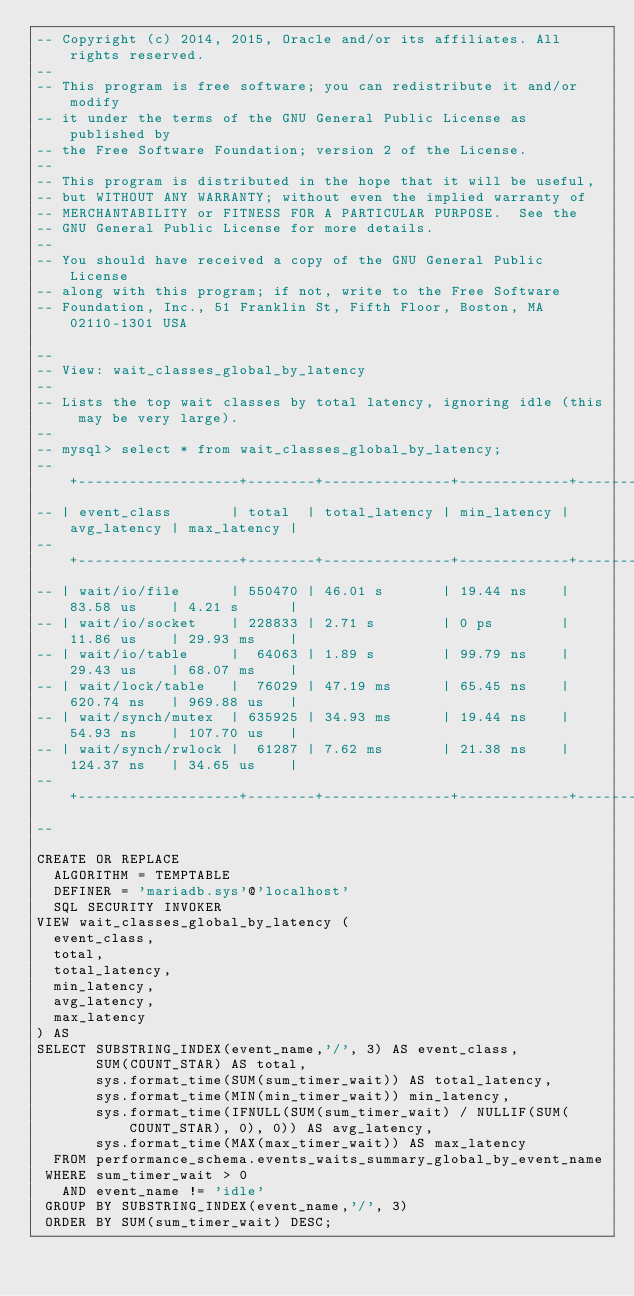Convert code to text. <code><loc_0><loc_0><loc_500><loc_500><_SQL_>-- Copyright (c) 2014, 2015, Oracle and/or its affiliates. All rights reserved.
--
-- This program is free software; you can redistribute it and/or modify
-- it under the terms of the GNU General Public License as published by
-- the Free Software Foundation; version 2 of the License.
--
-- This program is distributed in the hope that it will be useful,
-- but WITHOUT ANY WARRANTY; without even the implied warranty of
-- MERCHANTABILITY or FITNESS FOR A PARTICULAR PURPOSE.  See the
-- GNU General Public License for more details.
--
-- You should have received a copy of the GNU General Public License
-- along with this program; if not, write to the Free Software
-- Foundation, Inc., 51 Franklin St, Fifth Floor, Boston, MA 02110-1301 USA

--
-- View: wait_classes_global_by_latency
-- 
-- Lists the top wait classes by total latency, ignoring idle (this may be very large).
--
-- mysql> select * from wait_classes_global_by_latency;
-- +-------------------+--------+---------------+-------------+-------------+-------------+
-- | event_class       | total  | total_latency | min_latency | avg_latency | max_latency |
-- +-------------------+--------+---------------+-------------+-------------+-------------+
-- | wait/io/file      | 550470 | 46.01 s       | 19.44 ns    | 83.58 us    | 4.21 s      |
-- | wait/io/socket    | 228833 | 2.71 s        | 0 ps        | 11.86 us    | 29.93 ms    |
-- | wait/io/table     |  64063 | 1.89 s        | 99.79 ns    | 29.43 us    | 68.07 ms    |
-- | wait/lock/table   |  76029 | 47.19 ms      | 65.45 ns    | 620.74 ns   | 969.88 us   |
-- | wait/synch/mutex  | 635925 | 34.93 ms      | 19.44 ns    | 54.93 ns    | 107.70 us   |
-- | wait/synch/rwlock |  61287 | 7.62 ms       | 21.38 ns    | 124.37 ns   | 34.65 us    |
-- +-------------------+--------+---------------+-------------+-------------+-------------+
--

CREATE OR REPLACE
  ALGORITHM = TEMPTABLE
  DEFINER = 'mariadb.sys'@'localhost'
  SQL SECURITY INVOKER 
VIEW wait_classes_global_by_latency (
  event_class,
  total,
  total_latency,
  min_latency,
  avg_latency,
  max_latency
) AS
SELECT SUBSTRING_INDEX(event_name,'/', 3) AS event_class, 
       SUM(COUNT_STAR) AS total,
       sys.format_time(SUM(sum_timer_wait)) AS total_latency,
       sys.format_time(MIN(min_timer_wait)) min_latency,
       sys.format_time(IFNULL(SUM(sum_timer_wait) / NULLIF(SUM(COUNT_STAR), 0), 0)) AS avg_latency,
       sys.format_time(MAX(max_timer_wait)) AS max_latency
  FROM performance_schema.events_waits_summary_global_by_event_name
 WHERE sum_timer_wait > 0
   AND event_name != 'idle'
 GROUP BY SUBSTRING_INDEX(event_name,'/', 3) 
 ORDER BY SUM(sum_timer_wait) DESC;
</code> 